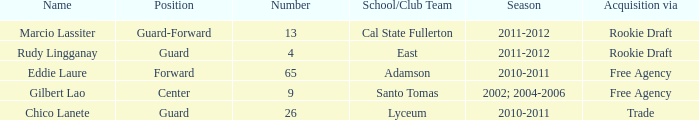What season had an acquisition of free agency, and was higher than 9? 2010-2011. 